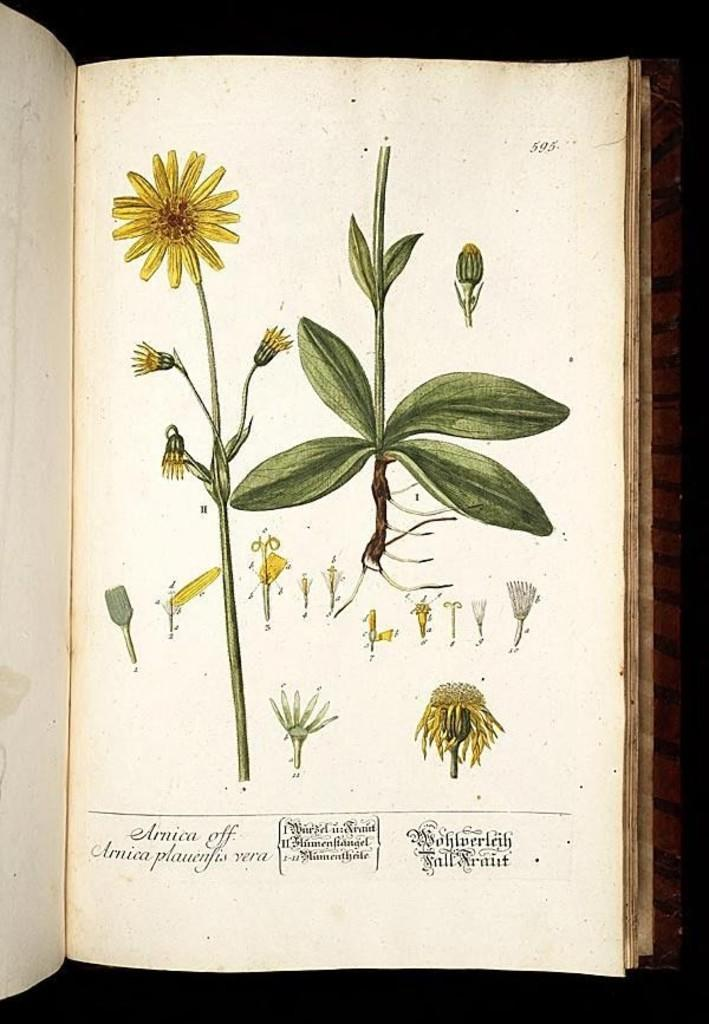What is the main subject of the image? The main subject of the image is an open book. What decorative elements are present on the book? Flowers, leaves, and stems are visible on the book. How would you describe the background of the image? The background of the image has a dark view. Can you tell me how many airplanes are parked next to the book in the image? There are no airplanes present in the image; it features an open book with decorative elements. What type of flowers are growing out of the van in the image? There is no van present in the image; it features an open book with decorative elements. 